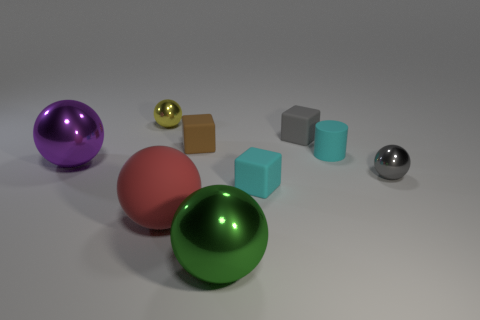Subtract all purple balls. How many balls are left? 4 Subtract all big red rubber balls. How many balls are left? 4 Subtract all brown balls. Subtract all red blocks. How many balls are left? 5 Add 1 tiny purple metallic blocks. How many objects exist? 10 Subtract all balls. How many objects are left? 4 Add 1 tiny brown things. How many tiny brown things exist? 2 Subtract 1 yellow spheres. How many objects are left? 8 Subtract all tiny green rubber cubes. Subtract all small cyan objects. How many objects are left? 7 Add 4 small cyan cylinders. How many small cyan cylinders are left? 5 